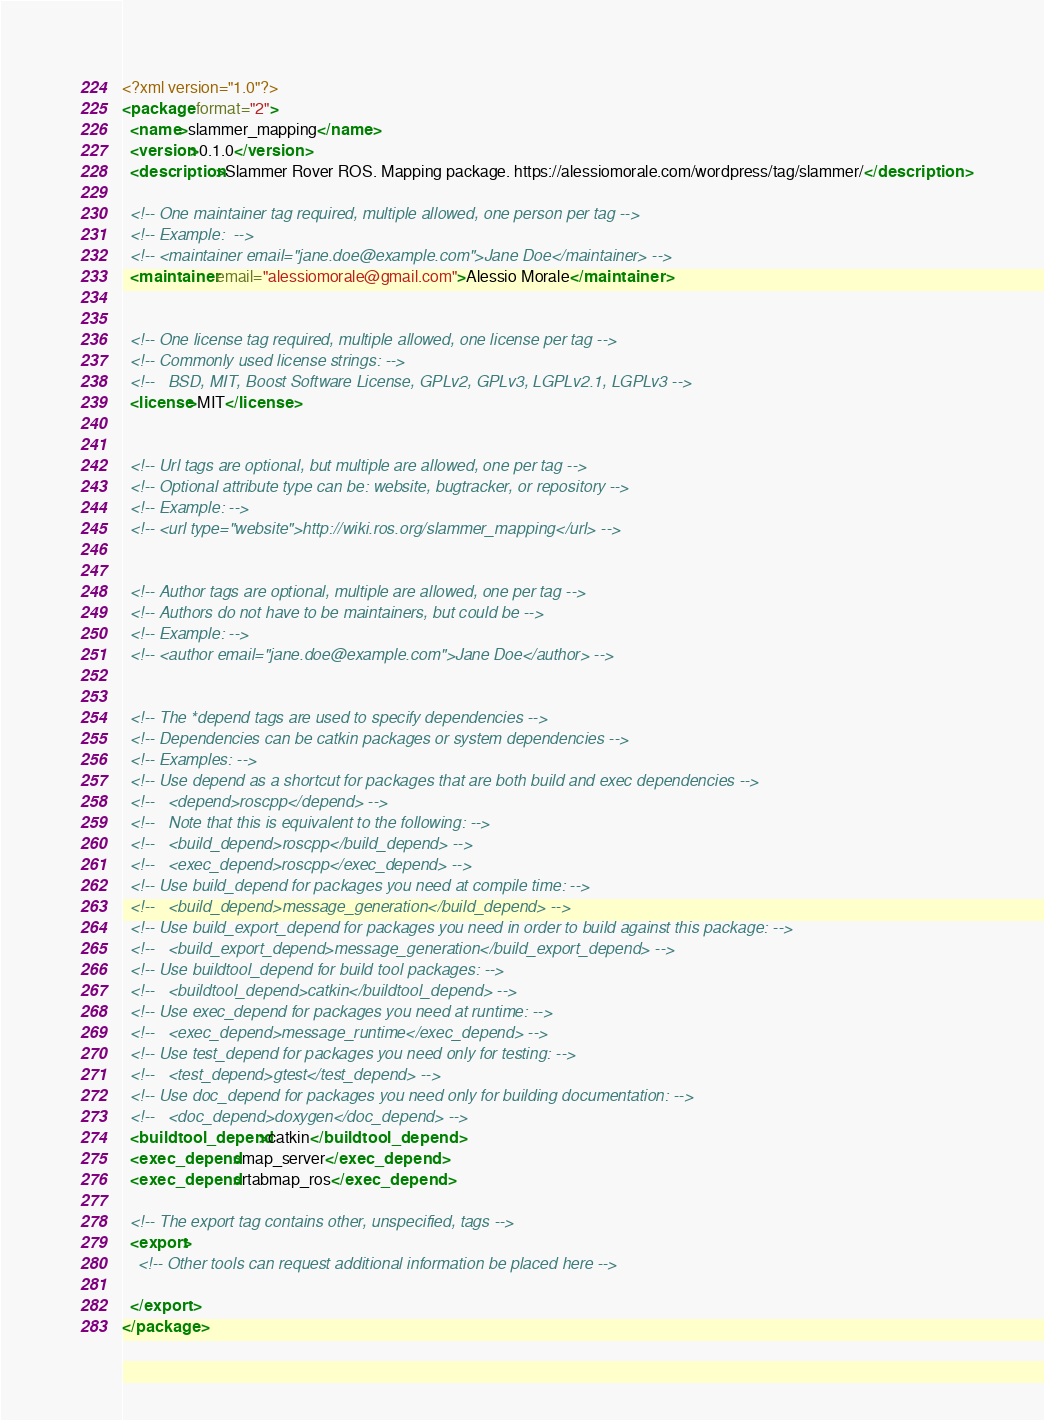<code> <loc_0><loc_0><loc_500><loc_500><_XML_><?xml version="1.0"?>
<package format="2">
  <name>slammer_mapping</name>
  <version>0.1.0</version>
  <description>Slammer Rover ROS. Mapping package. https://alessiomorale.com/wordpress/tag/slammer/</description>

  <!-- One maintainer tag required, multiple allowed, one person per tag -->
  <!-- Example:  -->
  <!-- <maintainer email="jane.doe@example.com">Jane Doe</maintainer> -->
  <maintainer email="alessiomorale@gmail.com">Alessio Morale</maintainer>


  <!-- One license tag required, multiple allowed, one license per tag -->
  <!-- Commonly used license strings: -->
  <!--   BSD, MIT, Boost Software License, GPLv2, GPLv3, LGPLv2.1, LGPLv3 -->
  <license>MIT</license>


  <!-- Url tags are optional, but multiple are allowed, one per tag -->
  <!-- Optional attribute type can be: website, bugtracker, or repository -->
  <!-- Example: -->
  <!-- <url type="website">http://wiki.ros.org/slammer_mapping</url> -->


  <!-- Author tags are optional, multiple are allowed, one per tag -->
  <!-- Authors do not have to be maintainers, but could be -->
  <!-- Example: -->
  <!-- <author email="jane.doe@example.com">Jane Doe</author> -->


  <!-- The *depend tags are used to specify dependencies -->
  <!-- Dependencies can be catkin packages or system dependencies -->
  <!-- Examples: -->
  <!-- Use depend as a shortcut for packages that are both build and exec dependencies -->
  <!--   <depend>roscpp</depend> -->
  <!--   Note that this is equivalent to the following: -->
  <!--   <build_depend>roscpp</build_depend> -->
  <!--   <exec_depend>roscpp</exec_depend> -->
  <!-- Use build_depend for packages you need at compile time: -->
  <!--   <build_depend>message_generation</build_depend> -->
  <!-- Use build_export_depend for packages you need in order to build against this package: -->
  <!--   <build_export_depend>message_generation</build_export_depend> -->
  <!-- Use buildtool_depend for build tool packages: -->
  <!--   <buildtool_depend>catkin</buildtool_depend> -->
  <!-- Use exec_depend for packages you need at runtime: -->
  <!--   <exec_depend>message_runtime</exec_depend> -->
  <!-- Use test_depend for packages you need only for testing: -->
  <!--   <test_depend>gtest</test_depend> -->
  <!-- Use doc_depend for packages you need only for building documentation: -->
  <!--   <doc_depend>doxygen</doc_depend> -->
  <buildtool_depend>catkin</buildtool_depend>
  <exec_depend>map_server</exec_depend>
  <exec_depend>rtabmap_ros</exec_depend>

  <!-- The export tag contains other, unspecified, tags -->
  <export>
    <!-- Other tools can request additional information be placed here -->

  </export>
</package>
</code> 